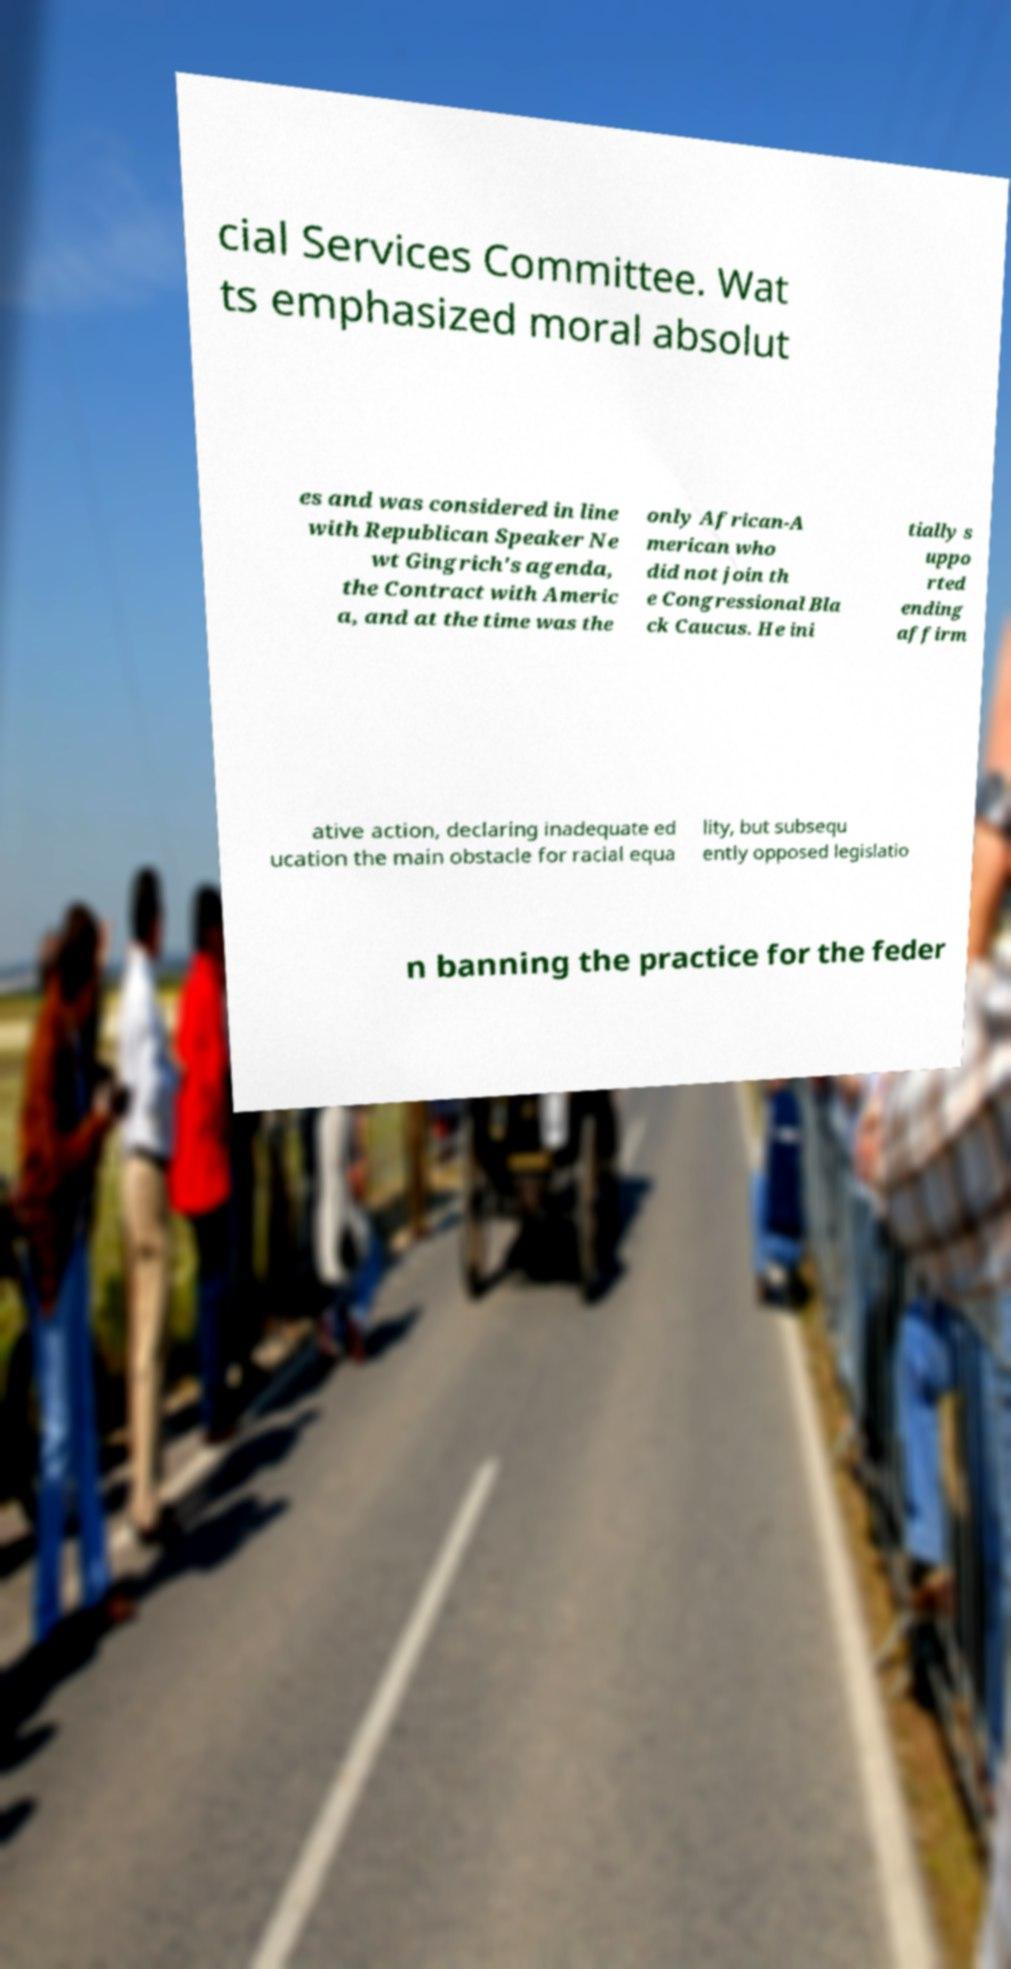For documentation purposes, I need the text within this image transcribed. Could you provide that? cial Services Committee. Wat ts emphasized moral absolut es and was considered in line with Republican Speaker Ne wt Gingrich's agenda, the Contract with Americ a, and at the time was the only African-A merican who did not join th e Congressional Bla ck Caucus. He ini tially s uppo rted ending affirm ative action, declaring inadequate ed ucation the main obstacle for racial equa lity, but subsequ ently opposed legislatio n banning the practice for the feder 